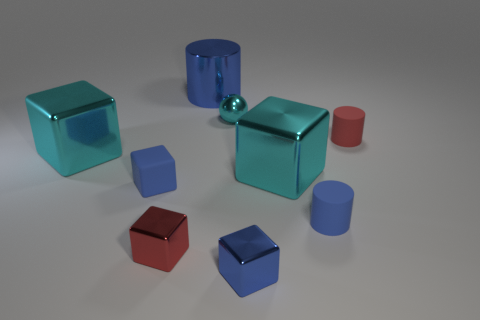Does the rubber block have the same color as the large cylinder?
Provide a succinct answer. Yes. There is a tiny red rubber cylinder; what number of blue metal cylinders are in front of it?
Give a very brief answer. 0. Are any red balls visible?
Offer a very short reply. No. There is a blue matte thing to the left of the tiny red object in front of the red object on the right side of the small cyan object; what is its size?
Provide a succinct answer. Small. What number of other objects are there of the same size as the red block?
Keep it short and to the point. 5. There is a metal cube that is left of the red cube; what is its size?
Ensure brevity in your answer.  Large. Is there any other thing that has the same color as the matte cube?
Make the answer very short. Yes. Is the small blue object that is in front of the small red block made of the same material as the big cylinder?
Offer a terse response. Yes. What number of big cyan blocks are both on the right side of the rubber cube and left of the ball?
Your answer should be compact. 0. There is a metal block that is to the right of the blue metallic object that is in front of the small matte block; how big is it?
Your response must be concise. Large. 